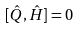<formula> <loc_0><loc_0><loc_500><loc_500>[ \hat { Q } , \hat { H } ] = 0</formula> 